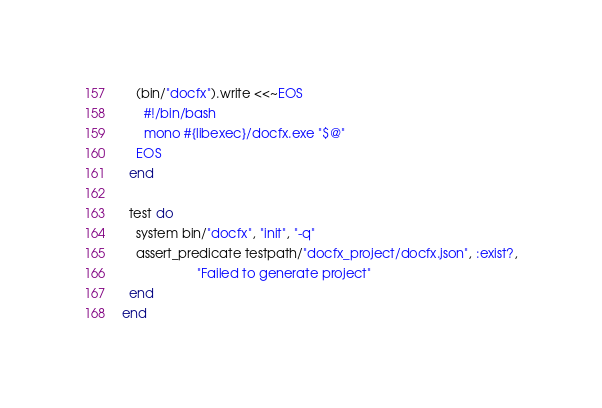<code> <loc_0><loc_0><loc_500><loc_500><_Ruby_>    (bin/"docfx").write <<~EOS
      #!/bin/bash
      mono #{libexec}/docfx.exe "$@"
    EOS
  end

  test do
    system bin/"docfx", "init", "-q"
    assert_predicate testpath/"docfx_project/docfx.json", :exist?,
                     "Failed to generate project"
  end
end
</code> 